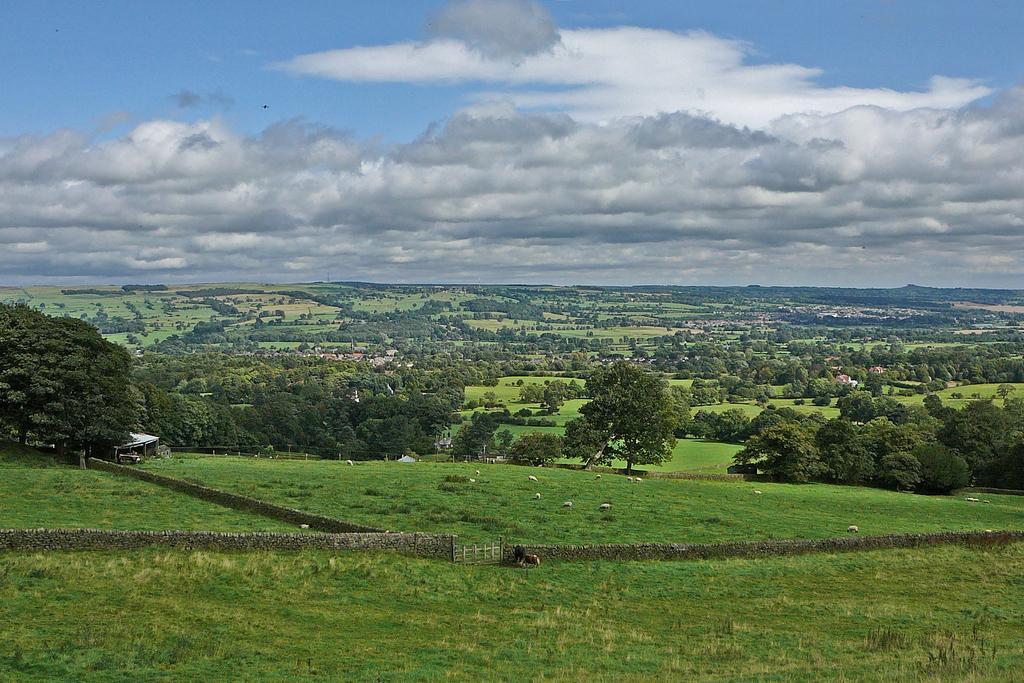Describe this image in one or two sentences. There are animals, on the grass on the ground. Around them, there is a wall with the gate. In the background, there are trees and clouds in the blue sky. 